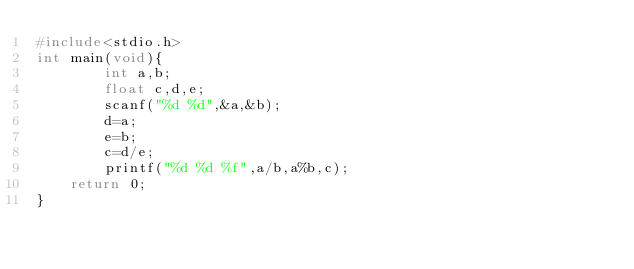<code> <loc_0><loc_0><loc_500><loc_500><_C_>#include<stdio.h>
int main(void){
        int a,b;
        float c,d,e;
        scanf("%d %d",&a,&b);
        d=a;
        e=b;
        c=d/e;
        printf("%d %d %f",a/b,a%b,c);
	return 0;
}</code> 